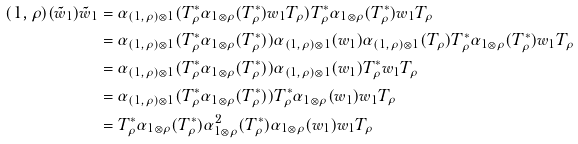<formula> <loc_0><loc_0><loc_500><loc_500>( 1 , \rho ) ( \tilde { w } _ { 1 } ) \tilde { w } _ { 1 } & = \alpha _ { ( 1 , \rho ) \otimes 1 } ( T _ { \rho } ^ { * } \alpha _ { 1 \otimes \rho } ( T _ { \rho } ^ { * } ) w _ { 1 } T _ { \rho } ) T _ { \rho } ^ { * } \alpha _ { 1 \otimes \rho } ( T _ { \rho } ^ { * } ) w _ { 1 } T _ { \rho } \\ & = \alpha _ { ( 1 , \rho ) \otimes 1 } ( T _ { \rho } ^ { * } \alpha _ { 1 \otimes \rho } ( T _ { \rho } ^ { * } ) ) \alpha _ { ( 1 , \rho ) \otimes 1 } ( w _ { 1 } ) \alpha _ { ( 1 , \rho ) \otimes 1 } ( T _ { \rho } ) T _ { \rho } ^ { * } \alpha _ { 1 \otimes \rho } ( T _ { \rho } ^ { * } ) w _ { 1 } T _ { \rho } \\ & = \alpha _ { ( 1 , \rho ) \otimes 1 } ( T _ { \rho } ^ { * } \alpha _ { 1 \otimes \rho } ( T _ { \rho } ^ { * } ) ) \alpha _ { ( 1 , \rho ) \otimes 1 } ( w _ { 1 } ) T _ { \rho } ^ { * } w _ { 1 } T _ { \rho } \\ & = \alpha _ { ( 1 , \rho ) \otimes 1 } ( T _ { \rho } ^ { * } \alpha _ { 1 \otimes \rho } ( T _ { \rho } ^ { * } ) ) T _ { \rho } ^ { * } \alpha _ { 1 \otimes \rho } ( w _ { 1 } ) w _ { 1 } T _ { \rho } \\ & = T _ { \rho } ^ { * } \alpha _ { 1 \otimes \rho } ( T _ { \rho } ^ { * } ) \alpha _ { 1 \otimes \rho } ^ { 2 } ( T _ { \rho } ^ { * } ) \alpha _ { 1 \otimes \rho } ( w _ { 1 } ) w _ { 1 } T _ { \rho }</formula> 